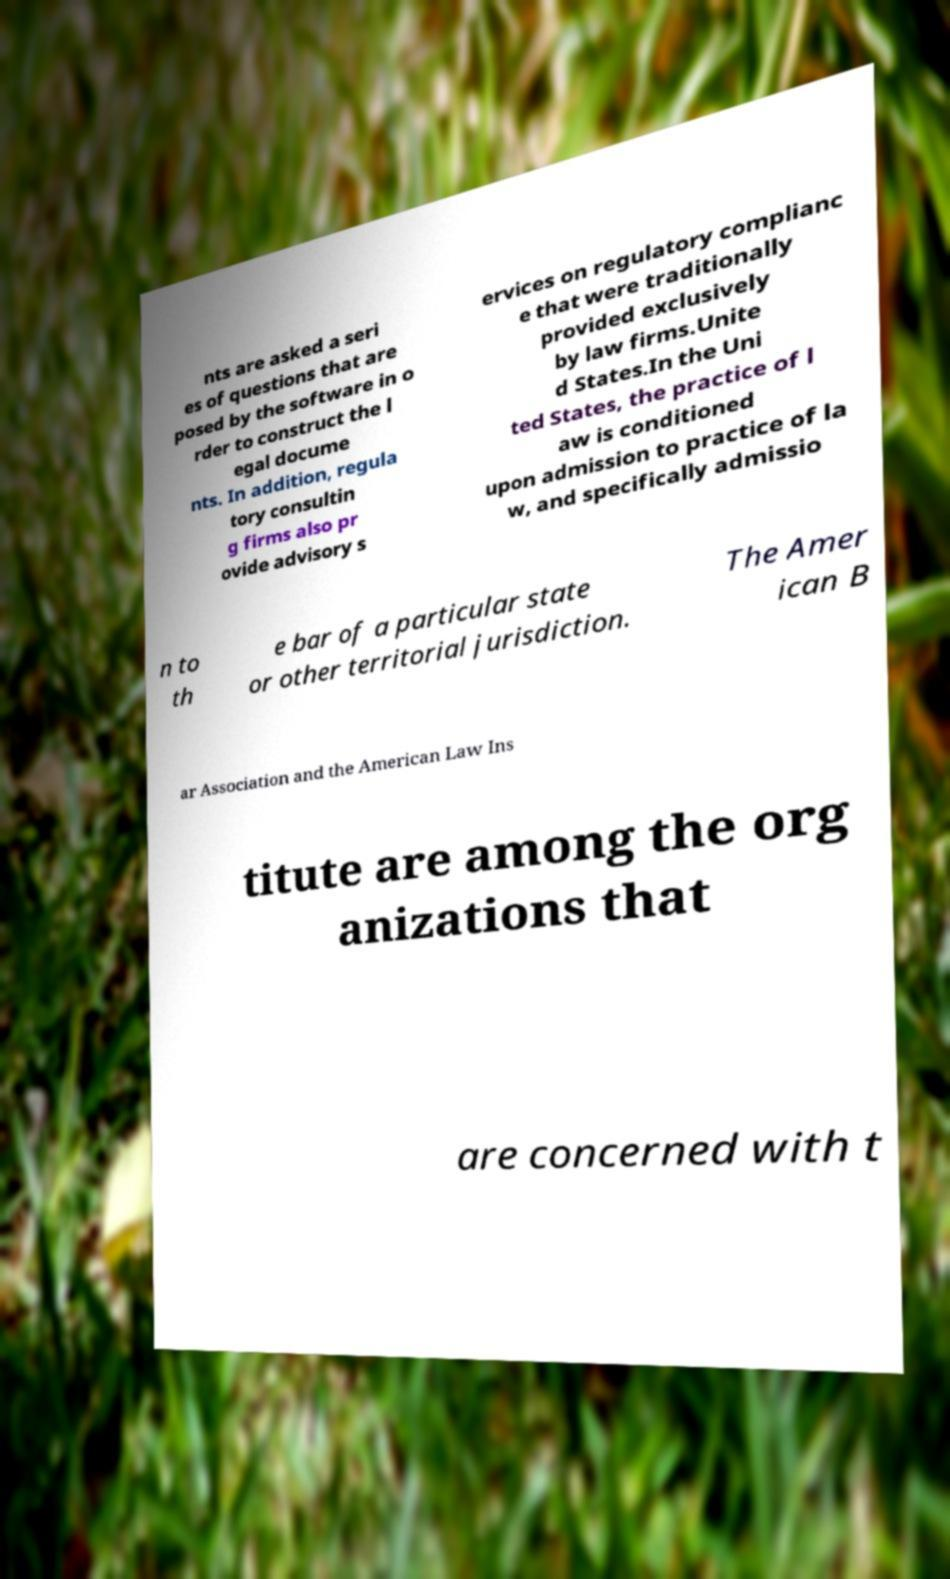I need the written content from this picture converted into text. Can you do that? nts are asked a seri es of questions that are posed by the software in o rder to construct the l egal docume nts. In addition, regula tory consultin g firms also pr ovide advisory s ervices on regulatory complianc e that were traditionally provided exclusively by law firms.Unite d States.In the Uni ted States, the practice of l aw is conditioned upon admission to practice of la w, and specifically admissio n to th e bar of a particular state or other territorial jurisdiction. The Amer ican B ar Association and the American Law Ins titute are among the org anizations that are concerned with t 